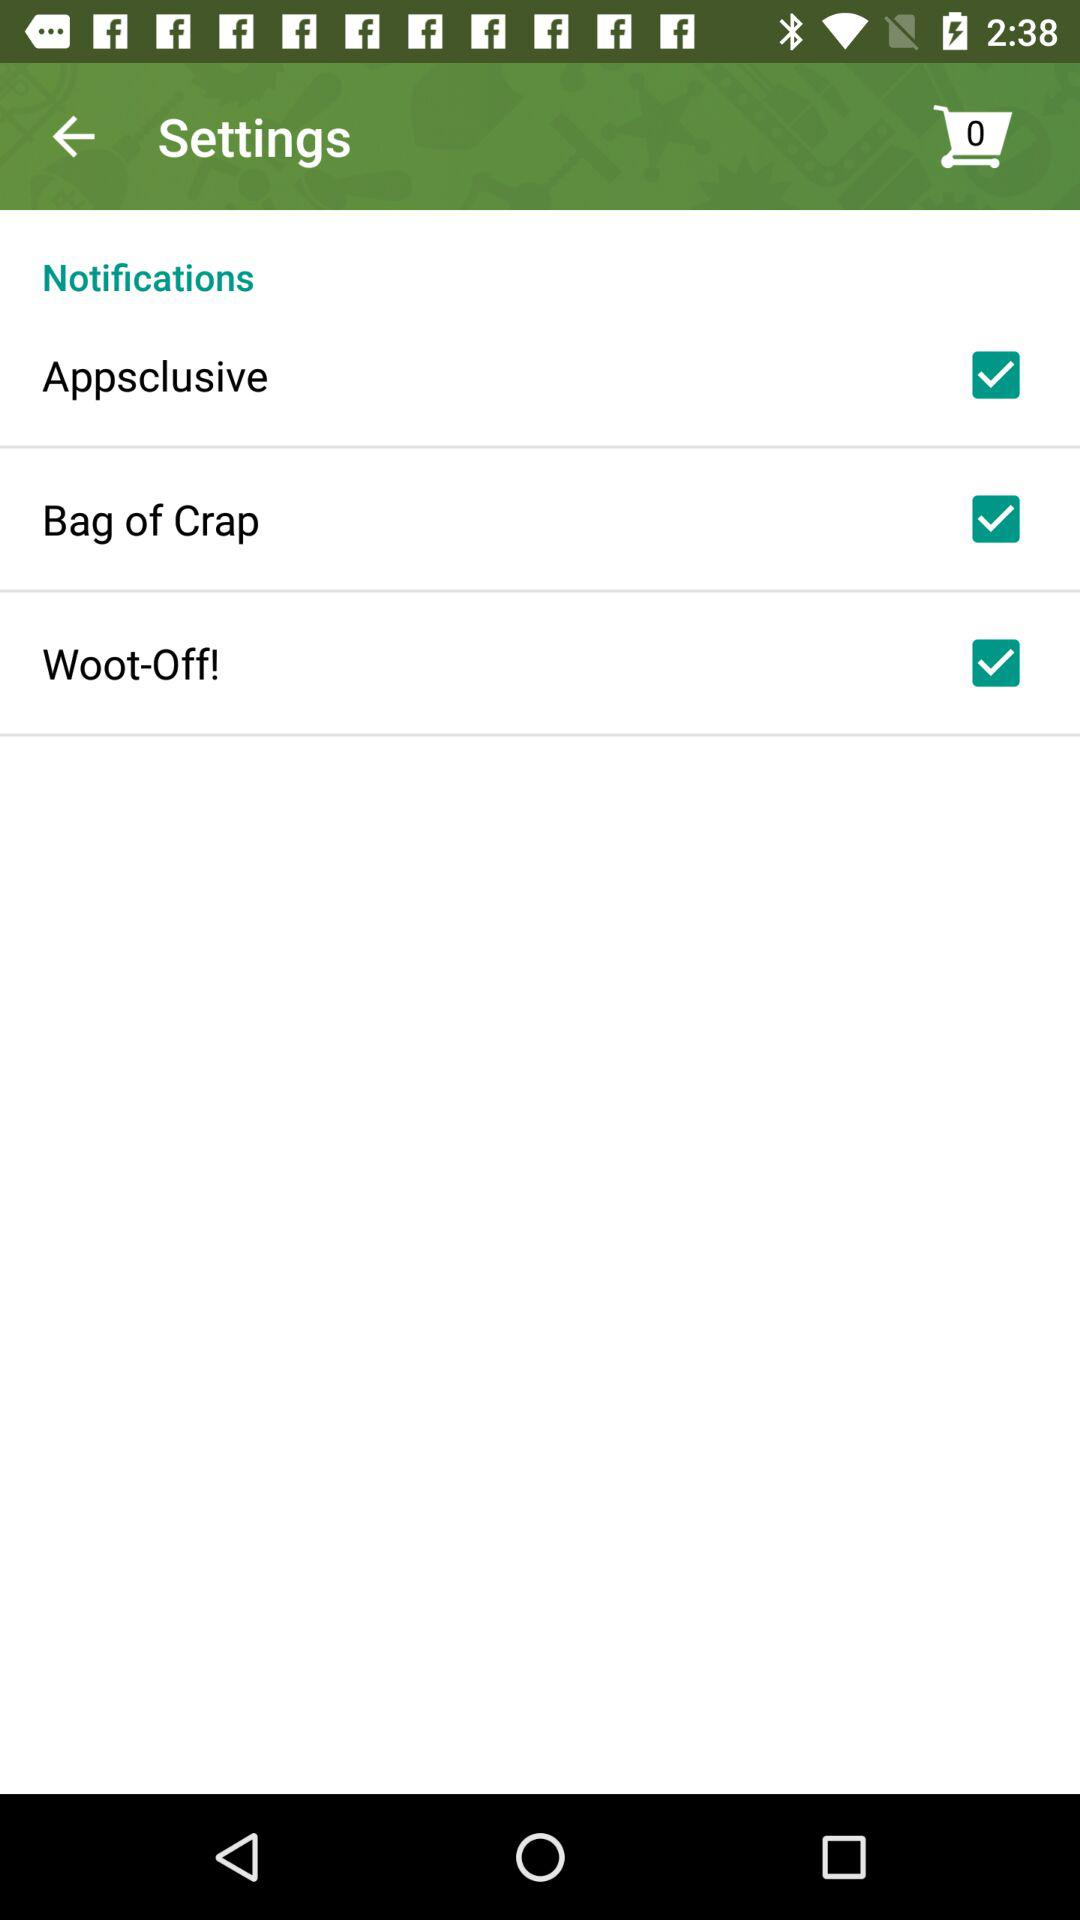What is the number of items in the shopping cart? There are zero items in the shopping cart. 